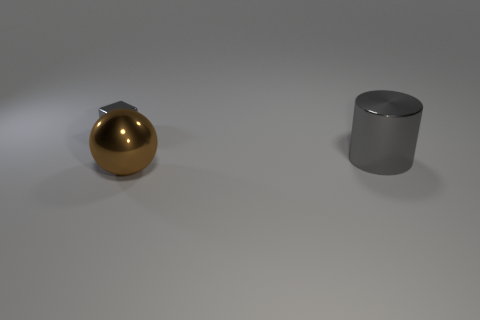Add 3 large gray metallic objects. How many objects exist? 6 Subtract all blocks. How many objects are left? 2 Subtract all large yellow matte things. Subtract all brown metallic spheres. How many objects are left? 2 Add 3 brown shiny balls. How many brown shiny balls are left? 4 Add 3 small shiny blocks. How many small shiny blocks exist? 4 Subtract 0 purple spheres. How many objects are left? 3 